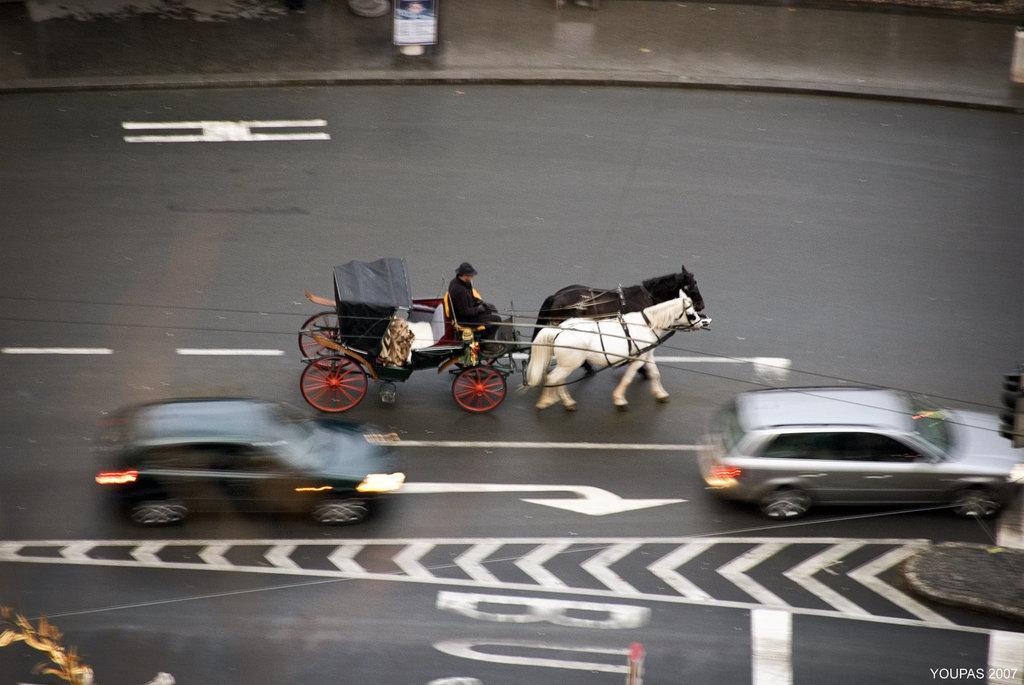In one or two sentences, can you explain what this image depicts? This is the man sitting and riding the horse cart. I can see two cars moving on the road. At the top of the image, that looks like a board. This is a road with the margins on it. At the bottom right corner of the image, I can see the watermark. 